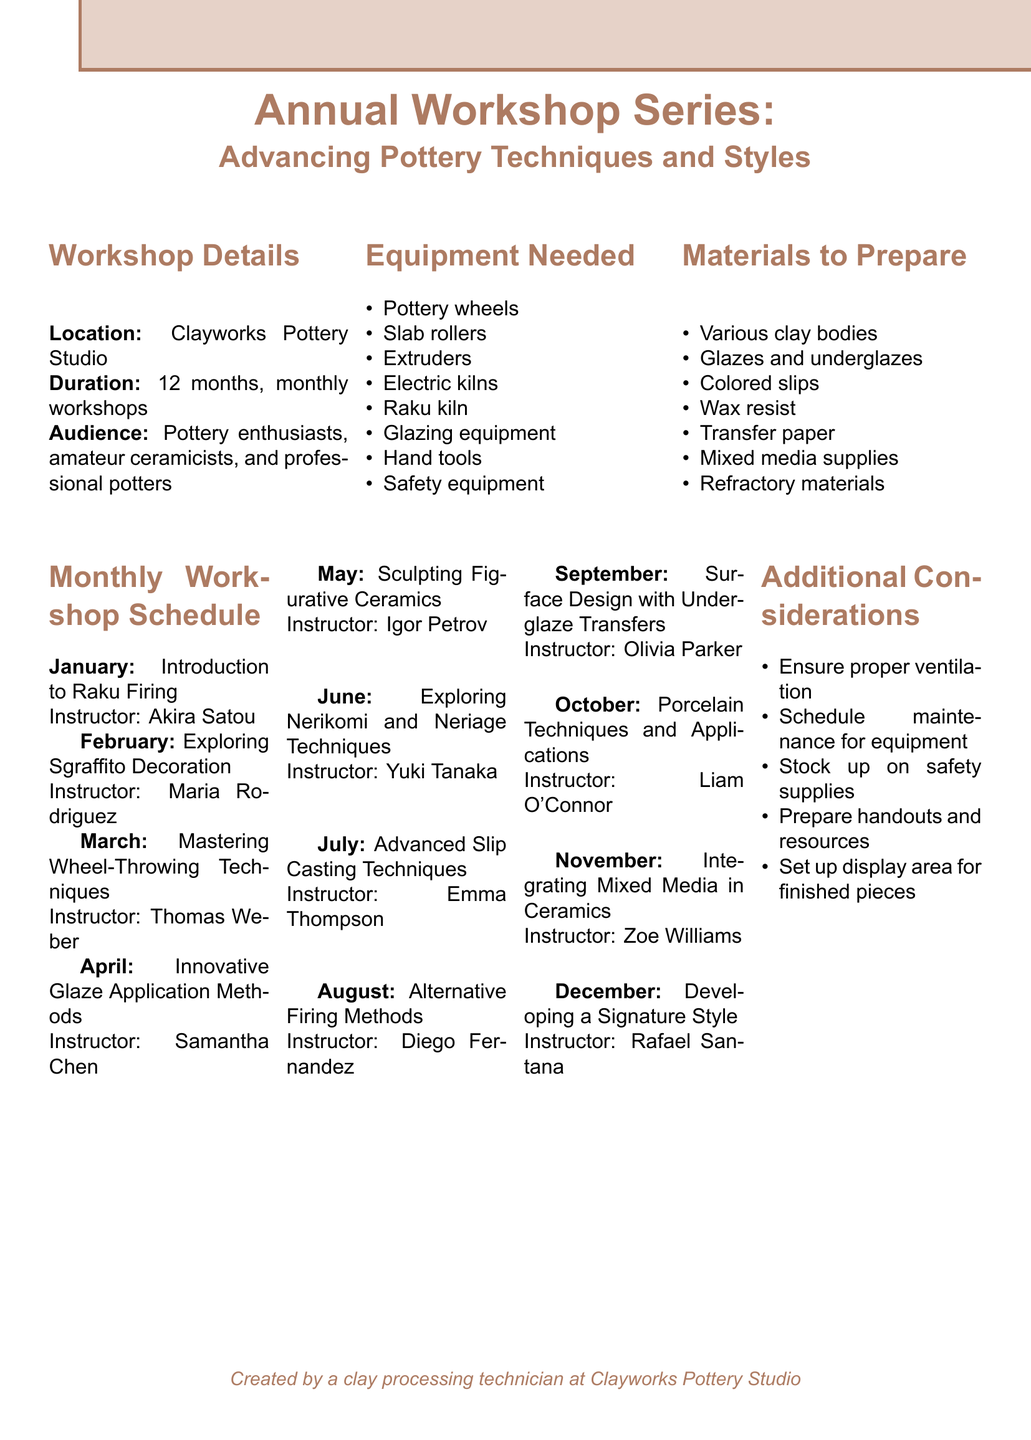What is the workshop title? The workshop title is stated in the document.
Answer: Annual Workshop Series: Advancing Pottery Techniques and Styles Who is the instructor for the June workshop? The instructor for the June workshop is mentioned under the corresponding month.
Answer: Yuki Tanaka How many months does the workshop series last? The duration of the workshop series is explicitly mentioned in the document.
Answer: 12 months Which month covers the topic "Advanced Slip Casting Techniques"? The month corresponding to that topic can be found in the workshop schedule section.
Answer: July What is one of the key points for the "Introduction to Raku Firing" workshop? A key point can be retrieved from the key points listed under the January workshop topic.
Answer: History and cultural significance of Raku What materials need to be prepared for the workshops? The materials needed for preparation are listed in a specific section of the document.
Answer: Various clay bodies (stoneware, porcelain, raku clay) Identify one safety consideration mentioned in the document. The document lists additional considerations including safety measures.
Answer: Ensure proper ventilation What is the purpose of the display area mentioned in the additional considerations? The purpose of the display area is noted in the context of showcasing works.
Answer: Finished pieces from each session 